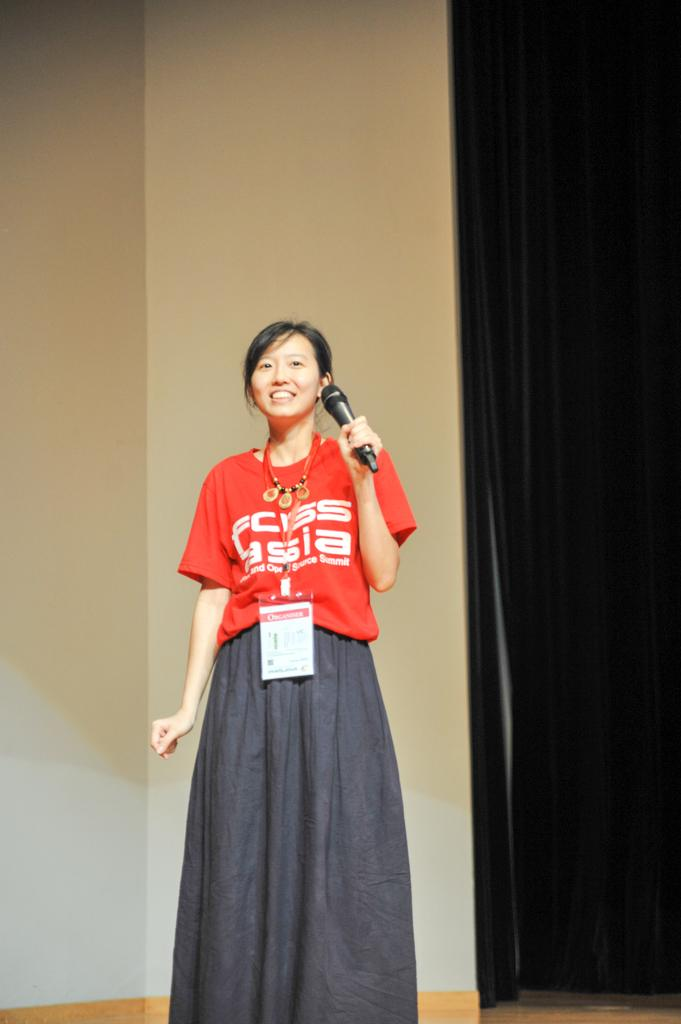Who is the main subject in the image? There is a woman in the image. What is the woman wearing? The woman is wearing a red t-shirt. What is the woman holding in the image? The woman is holding a microphone. Can you describe any accessories the woman is wearing? The woman is wearing an ID card. What can be seen in the background of the image? There is a black curtain in the image. What type of crown is the woman wearing in the image? There is no crown present in the image; the woman is wearing a red t-shirt and holding a microphone. 